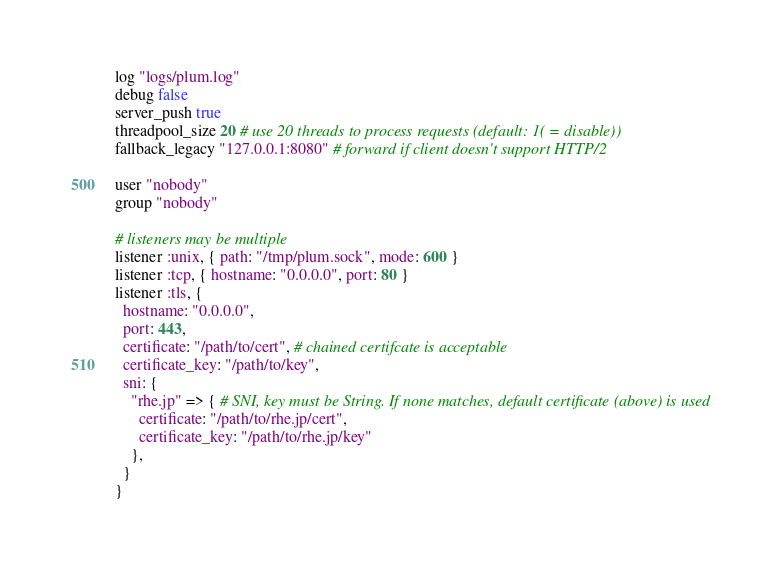<code> <loc_0><loc_0><loc_500><loc_500><_Ruby_>log "logs/plum.log"
debug false
server_push true
threadpool_size 20 # use 20 threads to process requests (default: 1( = disable))
fallback_legacy "127.0.0.1:8080" # forward if client doesn't support HTTP/2

user "nobody"
group "nobody"

# listeners may be multiple
listener :unix, { path: "/tmp/plum.sock", mode: 600 }
listener :tcp, { hostname: "0.0.0.0", port: 80 }
listener :tls, {
  hostname: "0.0.0.0",
  port: 443,
  certificate: "/path/to/cert", # chained certifcate is acceptable
  certificate_key: "/path/to/key",
  sni: {
    "rhe.jp" => { # SNI, key must be String. If none matches, default certificate (above) is used
      certificate: "/path/to/rhe.jp/cert",
      certificate_key: "/path/to/rhe.jp/key"
    },
  }
}
</code> 